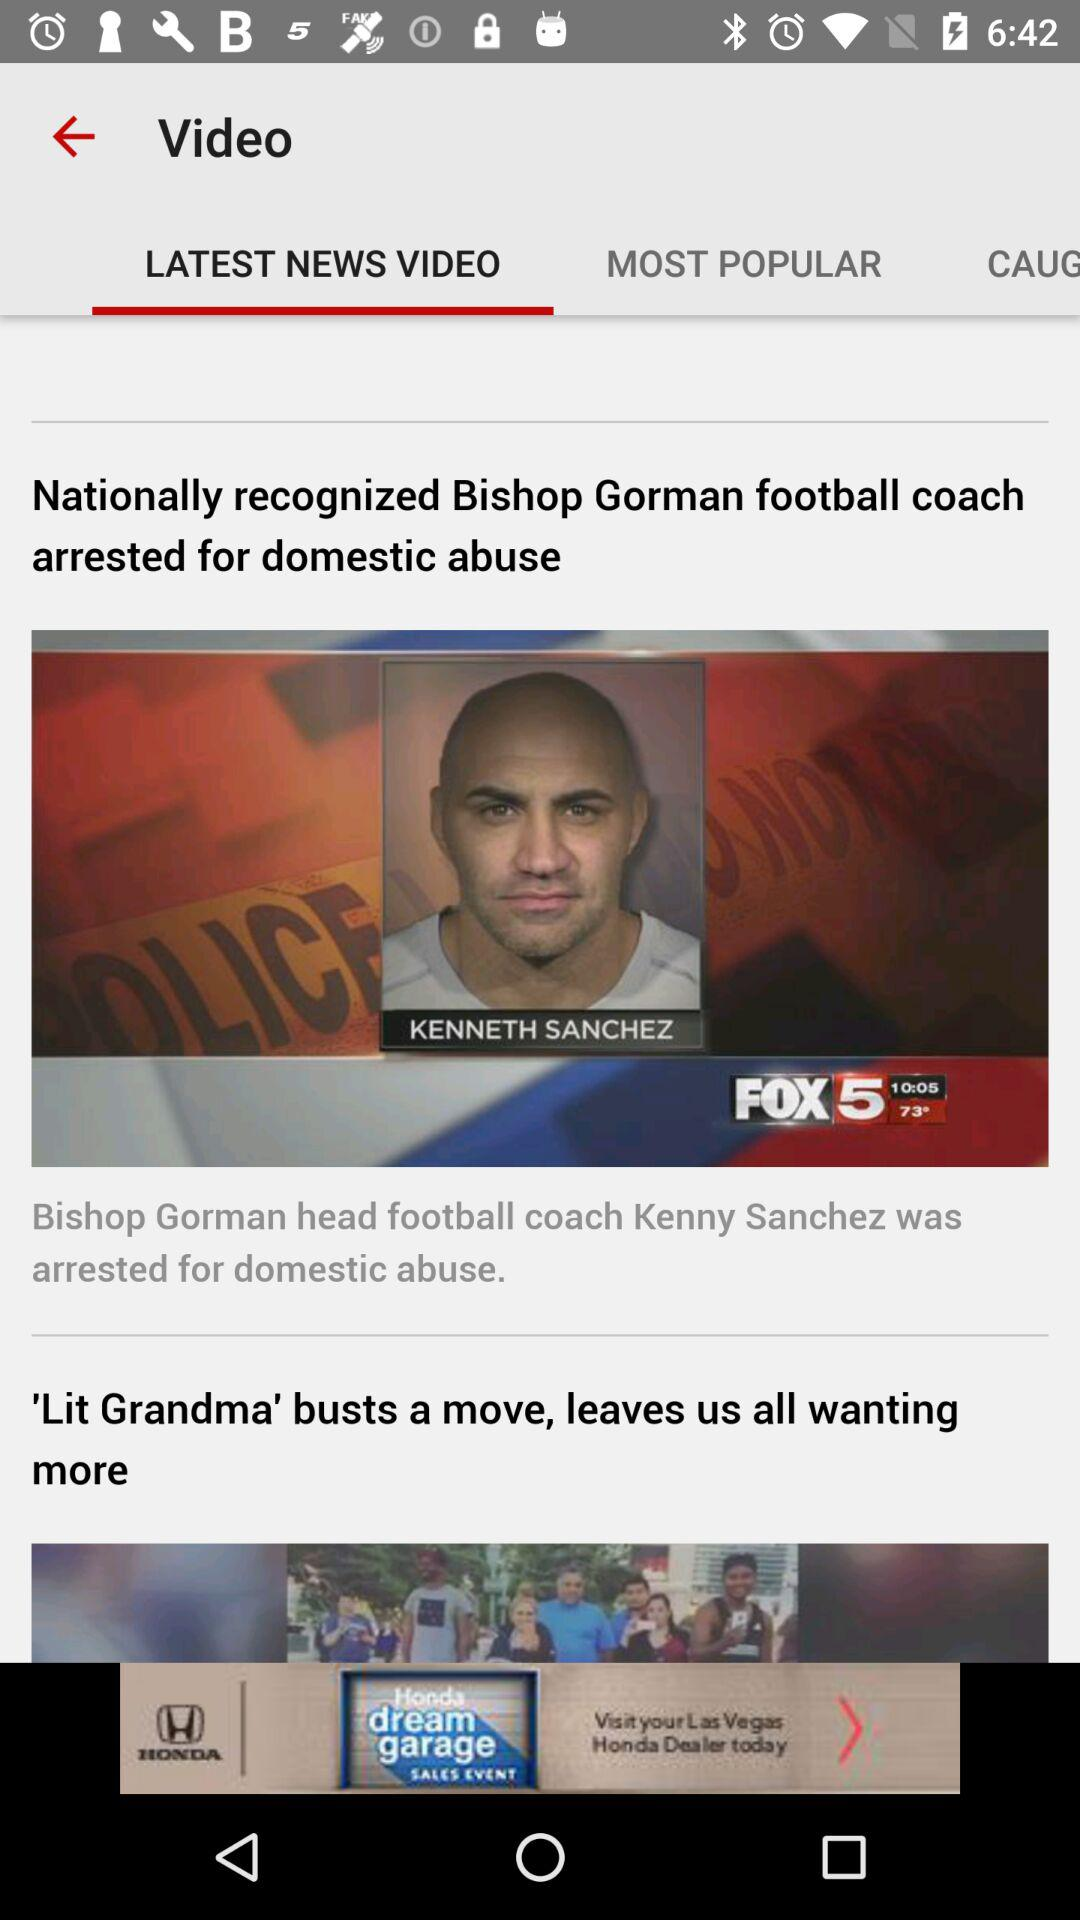What is the headline of the news about Kenneth Sanchez? The headline of the news about Kenneth Sanchez is "Nationally recognized Bishop Gorman football coach arrested for domestic abuse". 